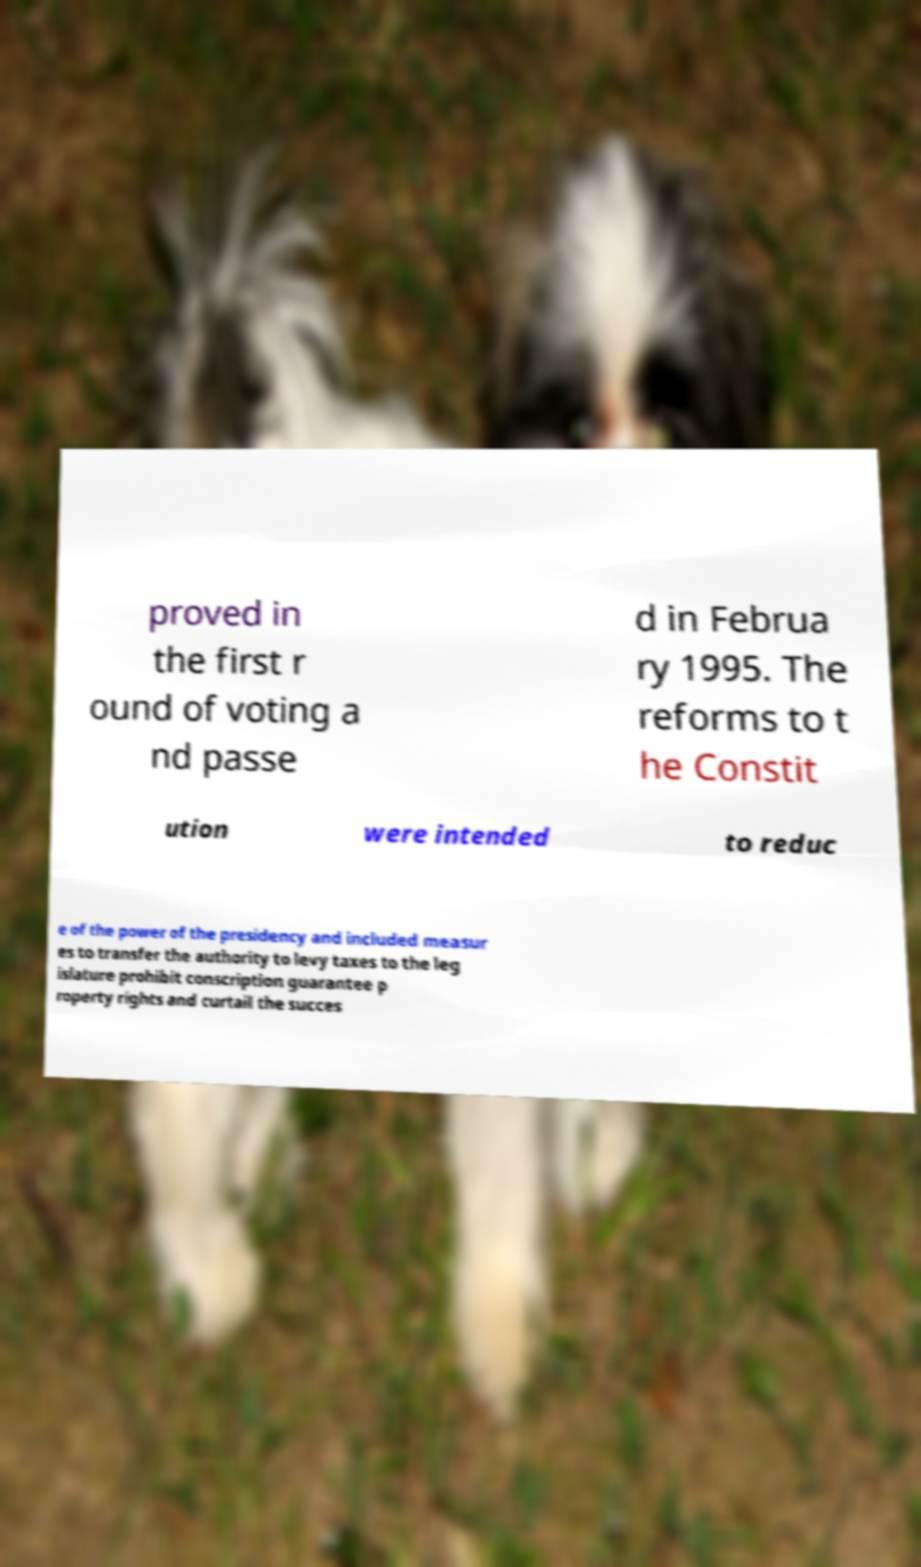Can you read and provide the text displayed in the image?This photo seems to have some interesting text. Can you extract and type it out for me? proved in the first r ound of voting a nd passe d in Februa ry 1995. The reforms to t he Constit ution were intended to reduc e of the power of the presidency and included measur es to transfer the authority to levy taxes to the leg islature prohibit conscription guarantee p roperty rights and curtail the succes 